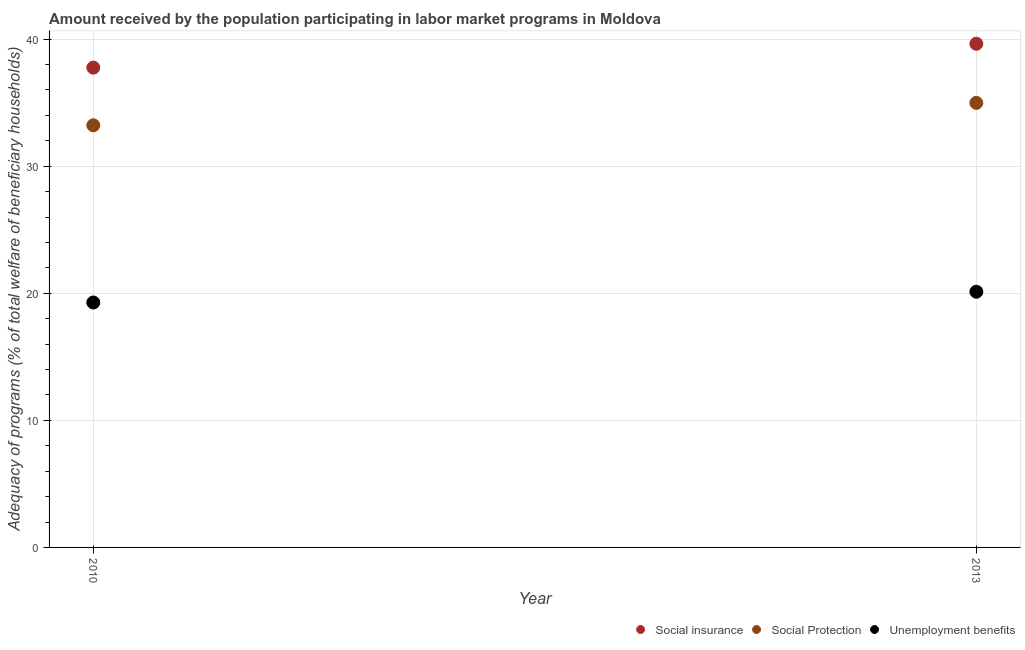How many different coloured dotlines are there?
Offer a terse response. 3. Is the number of dotlines equal to the number of legend labels?
Keep it short and to the point. Yes. What is the amount received by the population participating in unemployment benefits programs in 2010?
Ensure brevity in your answer.  19.28. Across all years, what is the maximum amount received by the population participating in social protection programs?
Keep it short and to the point. 34.98. Across all years, what is the minimum amount received by the population participating in unemployment benefits programs?
Ensure brevity in your answer.  19.28. What is the total amount received by the population participating in social protection programs in the graph?
Provide a succinct answer. 68.21. What is the difference between the amount received by the population participating in social insurance programs in 2010 and that in 2013?
Offer a terse response. -1.88. What is the difference between the amount received by the population participating in social protection programs in 2010 and the amount received by the population participating in social insurance programs in 2013?
Provide a short and direct response. -6.42. What is the average amount received by the population participating in social insurance programs per year?
Your answer should be compact. 38.7. In the year 2010, what is the difference between the amount received by the population participating in social insurance programs and amount received by the population participating in unemployment benefits programs?
Your answer should be very brief. 18.48. What is the ratio of the amount received by the population participating in social insurance programs in 2010 to that in 2013?
Offer a terse response. 0.95. Is the amount received by the population participating in social protection programs in 2010 less than that in 2013?
Make the answer very short. Yes. Is the amount received by the population participating in social insurance programs strictly greater than the amount received by the population participating in social protection programs over the years?
Provide a succinct answer. Yes. Is the amount received by the population participating in social protection programs strictly less than the amount received by the population participating in social insurance programs over the years?
Make the answer very short. Yes. How many years are there in the graph?
Make the answer very short. 2. What is the difference between two consecutive major ticks on the Y-axis?
Your answer should be very brief. 10. Are the values on the major ticks of Y-axis written in scientific E-notation?
Ensure brevity in your answer.  No. Does the graph contain grids?
Provide a succinct answer. Yes. Where does the legend appear in the graph?
Your answer should be very brief. Bottom right. What is the title of the graph?
Your answer should be compact. Amount received by the population participating in labor market programs in Moldova. What is the label or title of the X-axis?
Your response must be concise. Year. What is the label or title of the Y-axis?
Your answer should be compact. Adequacy of programs (% of total welfare of beneficiary households). What is the Adequacy of programs (% of total welfare of beneficiary households) of Social insurance in 2010?
Your answer should be compact. 37.76. What is the Adequacy of programs (% of total welfare of beneficiary households) of Social Protection in 2010?
Your answer should be very brief. 33.22. What is the Adequacy of programs (% of total welfare of beneficiary households) in Unemployment benefits in 2010?
Ensure brevity in your answer.  19.28. What is the Adequacy of programs (% of total welfare of beneficiary households) in Social insurance in 2013?
Offer a terse response. 39.64. What is the Adequacy of programs (% of total welfare of beneficiary households) of Social Protection in 2013?
Give a very brief answer. 34.98. What is the Adequacy of programs (% of total welfare of beneficiary households) in Unemployment benefits in 2013?
Your answer should be very brief. 20.12. Across all years, what is the maximum Adequacy of programs (% of total welfare of beneficiary households) in Social insurance?
Offer a very short reply. 39.64. Across all years, what is the maximum Adequacy of programs (% of total welfare of beneficiary households) in Social Protection?
Your response must be concise. 34.98. Across all years, what is the maximum Adequacy of programs (% of total welfare of beneficiary households) in Unemployment benefits?
Keep it short and to the point. 20.12. Across all years, what is the minimum Adequacy of programs (% of total welfare of beneficiary households) of Social insurance?
Give a very brief answer. 37.76. Across all years, what is the minimum Adequacy of programs (% of total welfare of beneficiary households) of Social Protection?
Keep it short and to the point. 33.22. Across all years, what is the minimum Adequacy of programs (% of total welfare of beneficiary households) in Unemployment benefits?
Offer a very short reply. 19.28. What is the total Adequacy of programs (% of total welfare of beneficiary households) in Social insurance in the graph?
Your response must be concise. 77.4. What is the total Adequacy of programs (% of total welfare of beneficiary households) of Social Protection in the graph?
Your response must be concise. 68.21. What is the total Adequacy of programs (% of total welfare of beneficiary households) of Unemployment benefits in the graph?
Keep it short and to the point. 39.4. What is the difference between the Adequacy of programs (% of total welfare of beneficiary households) in Social insurance in 2010 and that in 2013?
Your answer should be very brief. -1.88. What is the difference between the Adequacy of programs (% of total welfare of beneficiary households) of Social Protection in 2010 and that in 2013?
Offer a terse response. -1.76. What is the difference between the Adequacy of programs (% of total welfare of beneficiary households) of Unemployment benefits in 2010 and that in 2013?
Your answer should be compact. -0.85. What is the difference between the Adequacy of programs (% of total welfare of beneficiary households) in Social insurance in 2010 and the Adequacy of programs (% of total welfare of beneficiary households) in Social Protection in 2013?
Make the answer very short. 2.78. What is the difference between the Adequacy of programs (% of total welfare of beneficiary households) in Social insurance in 2010 and the Adequacy of programs (% of total welfare of beneficiary households) in Unemployment benefits in 2013?
Provide a short and direct response. 17.64. What is the difference between the Adequacy of programs (% of total welfare of beneficiary households) of Social Protection in 2010 and the Adequacy of programs (% of total welfare of beneficiary households) of Unemployment benefits in 2013?
Give a very brief answer. 13.1. What is the average Adequacy of programs (% of total welfare of beneficiary households) of Social insurance per year?
Offer a very short reply. 38.7. What is the average Adequacy of programs (% of total welfare of beneficiary households) of Social Protection per year?
Your response must be concise. 34.1. What is the average Adequacy of programs (% of total welfare of beneficiary households) in Unemployment benefits per year?
Provide a short and direct response. 19.7. In the year 2010, what is the difference between the Adequacy of programs (% of total welfare of beneficiary households) of Social insurance and Adequacy of programs (% of total welfare of beneficiary households) of Social Protection?
Your response must be concise. 4.54. In the year 2010, what is the difference between the Adequacy of programs (% of total welfare of beneficiary households) in Social insurance and Adequacy of programs (% of total welfare of beneficiary households) in Unemployment benefits?
Your response must be concise. 18.48. In the year 2010, what is the difference between the Adequacy of programs (% of total welfare of beneficiary households) of Social Protection and Adequacy of programs (% of total welfare of beneficiary households) of Unemployment benefits?
Offer a terse response. 13.95. In the year 2013, what is the difference between the Adequacy of programs (% of total welfare of beneficiary households) of Social insurance and Adequacy of programs (% of total welfare of beneficiary households) of Social Protection?
Ensure brevity in your answer.  4.65. In the year 2013, what is the difference between the Adequacy of programs (% of total welfare of beneficiary households) in Social insurance and Adequacy of programs (% of total welfare of beneficiary households) in Unemployment benefits?
Offer a very short reply. 19.52. In the year 2013, what is the difference between the Adequacy of programs (% of total welfare of beneficiary households) in Social Protection and Adequacy of programs (% of total welfare of beneficiary households) in Unemployment benefits?
Your answer should be compact. 14.86. What is the ratio of the Adequacy of programs (% of total welfare of beneficiary households) in Social insurance in 2010 to that in 2013?
Make the answer very short. 0.95. What is the ratio of the Adequacy of programs (% of total welfare of beneficiary households) of Social Protection in 2010 to that in 2013?
Your response must be concise. 0.95. What is the ratio of the Adequacy of programs (% of total welfare of beneficiary households) in Unemployment benefits in 2010 to that in 2013?
Your response must be concise. 0.96. What is the difference between the highest and the second highest Adequacy of programs (% of total welfare of beneficiary households) in Social insurance?
Ensure brevity in your answer.  1.88. What is the difference between the highest and the second highest Adequacy of programs (% of total welfare of beneficiary households) in Social Protection?
Provide a short and direct response. 1.76. What is the difference between the highest and the second highest Adequacy of programs (% of total welfare of beneficiary households) in Unemployment benefits?
Keep it short and to the point. 0.85. What is the difference between the highest and the lowest Adequacy of programs (% of total welfare of beneficiary households) of Social insurance?
Offer a very short reply. 1.88. What is the difference between the highest and the lowest Adequacy of programs (% of total welfare of beneficiary households) of Social Protection?
Give a very brief answer. 1.76. What is the difference between the highest and the lowest Adequacy of programs (% of total welfare of beneficiary households) in Unemployment benefits?
Provide a succinct answer. 0.85. 